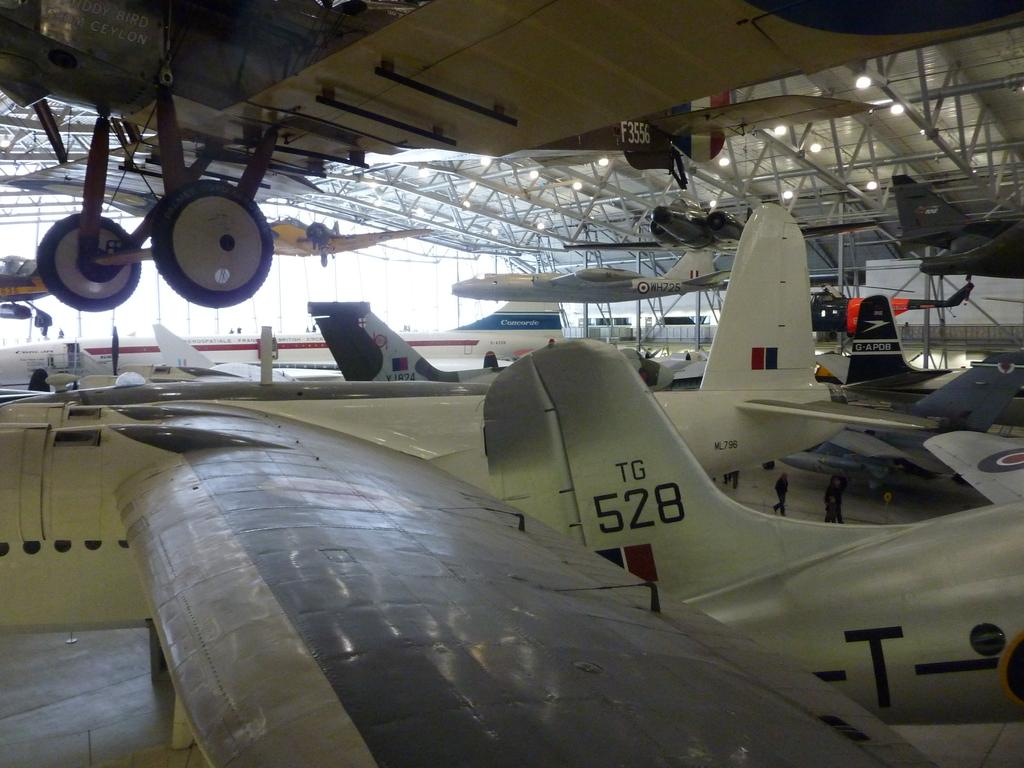What objects are being held up by rods under a shed in the image? There are airplanes held up by rods under a shed in the image. Are all the airplanes in the image held up by rods? No, some airplanes are placed on the ground in the image. What can be seen in the background of the image? There is a group of persons standing in the background. What type of heart-shaped island can be seen in the image? There is no island, heart-shaped or otherwise, present in the image. 